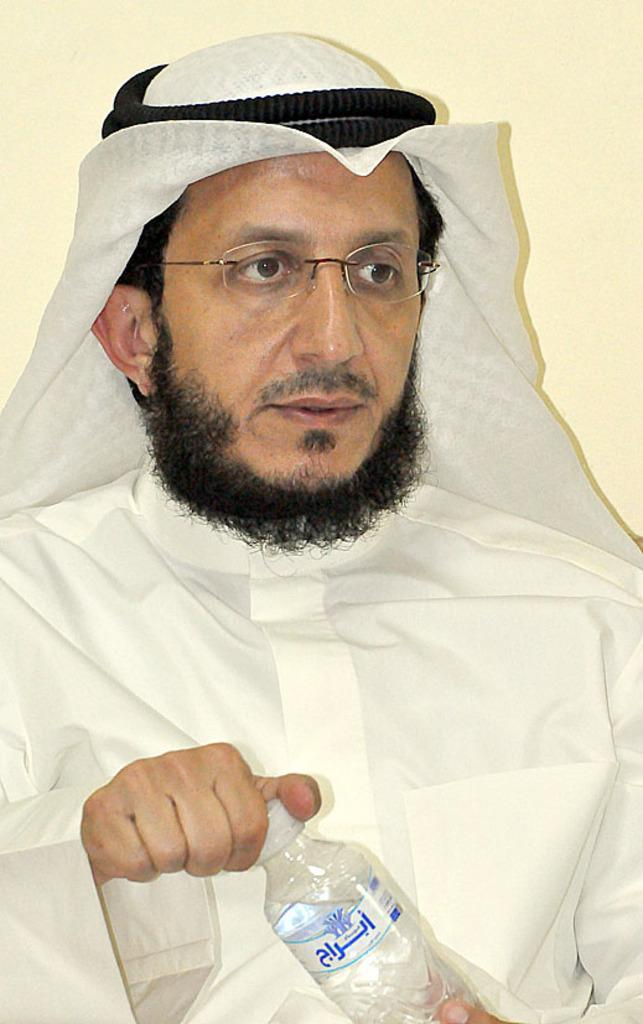Who or what is the main subject in the image? There is a person in the image. Where is the person located in the image? The person is in the center of the image. What is the person holding in his hand? The person is holding a water bottle in his hand. What type of bear can be seen walking next to the person in the image? There is no bear present in the image; it only features a person holding a water bottle. What kind of machine is being operated by the person in the image? There is no machine present in the image; the person is simply holding a water bottle. 